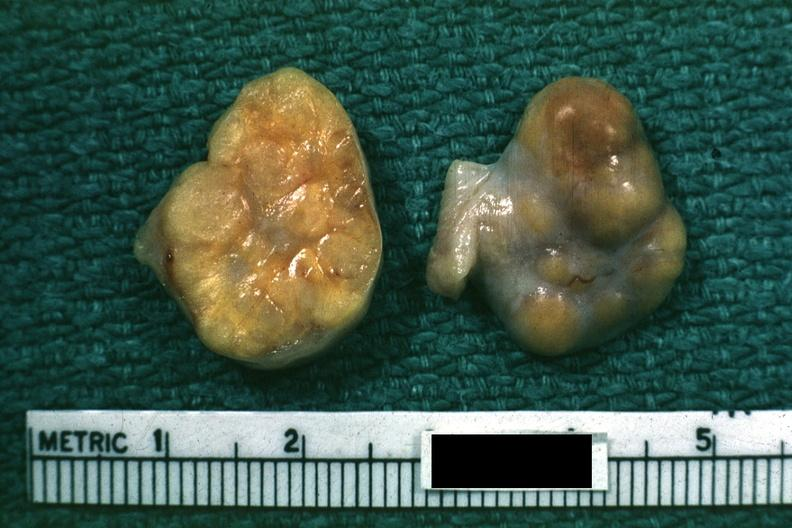s atrophy labeled granulosa cell tumor?
Answer the question using a single word or phrase. No 